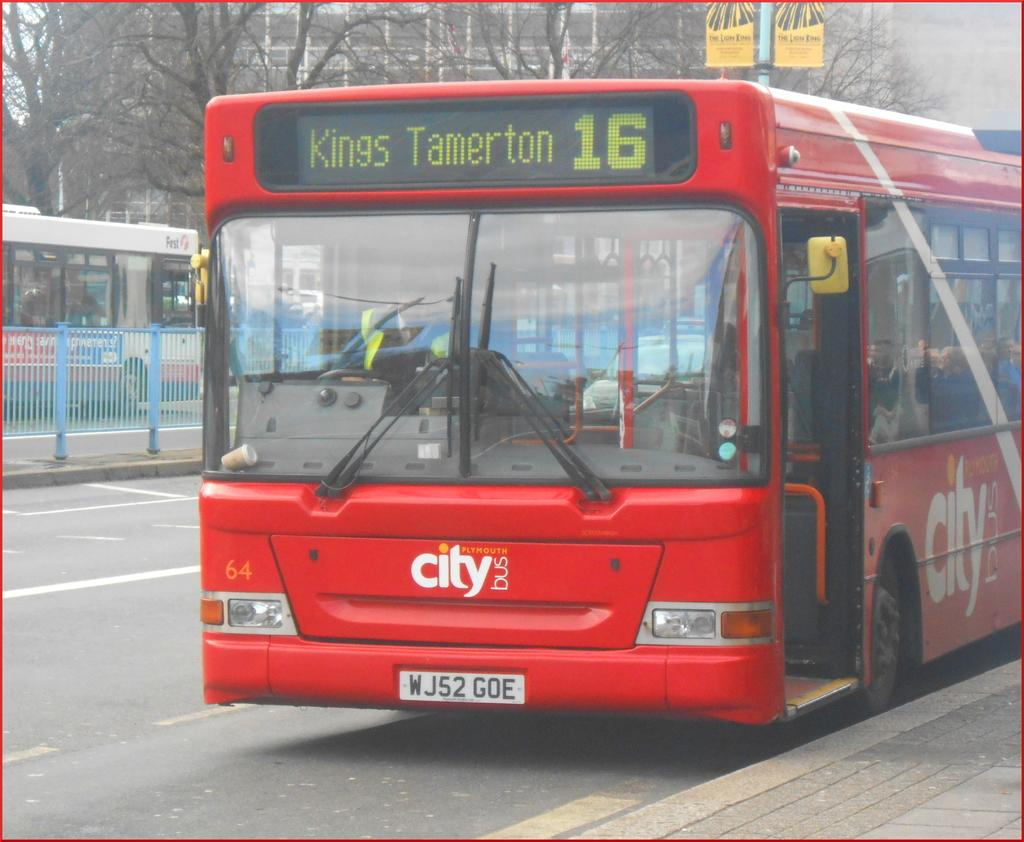<image>
Present a compact description of the photo's key features. A red Plymouth City Bus rides to Kings Tamerton. 